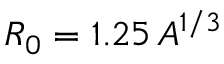Convert formula to latex. <formula><loc_0><loc_0><loc_500><loc_500>R _ { 0 } = 1 . 2 5 \, A ^ { 1 / 3 }</formula> 